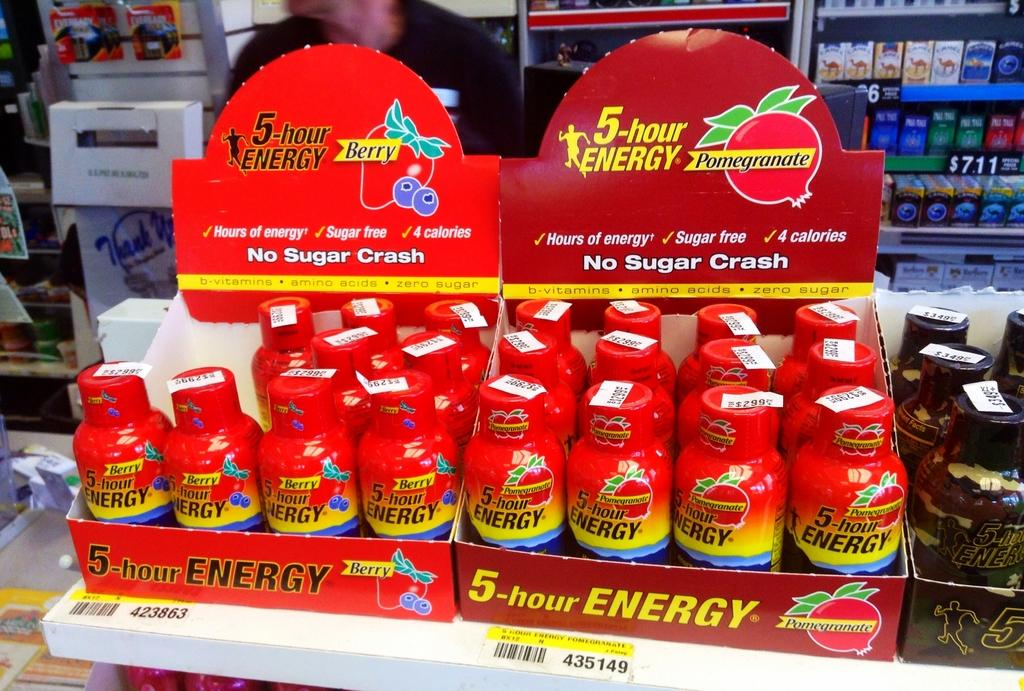<image>
Give a short and clear explanation of the subsequent image. Three displays of 5-Hour Energy Drink sit on a convenience store shelf. 